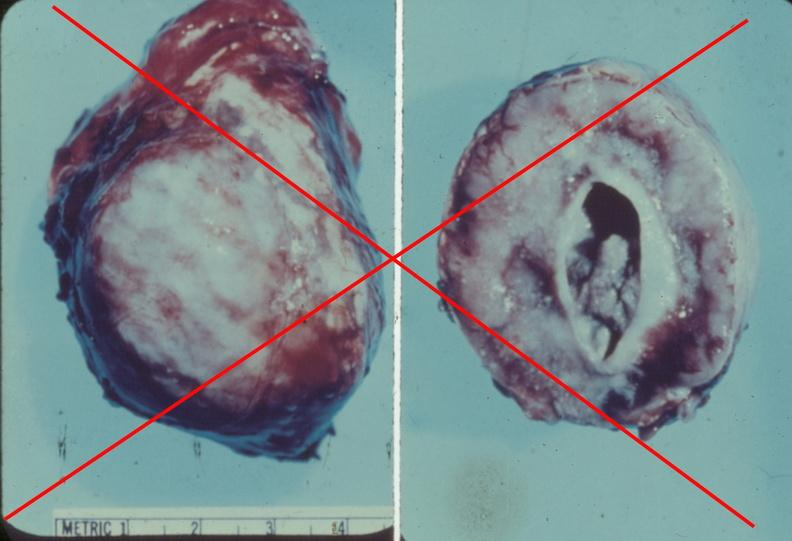does this image show adrenal phaeochromocytoma?
Answer the question using a single word or phrase. Yes 